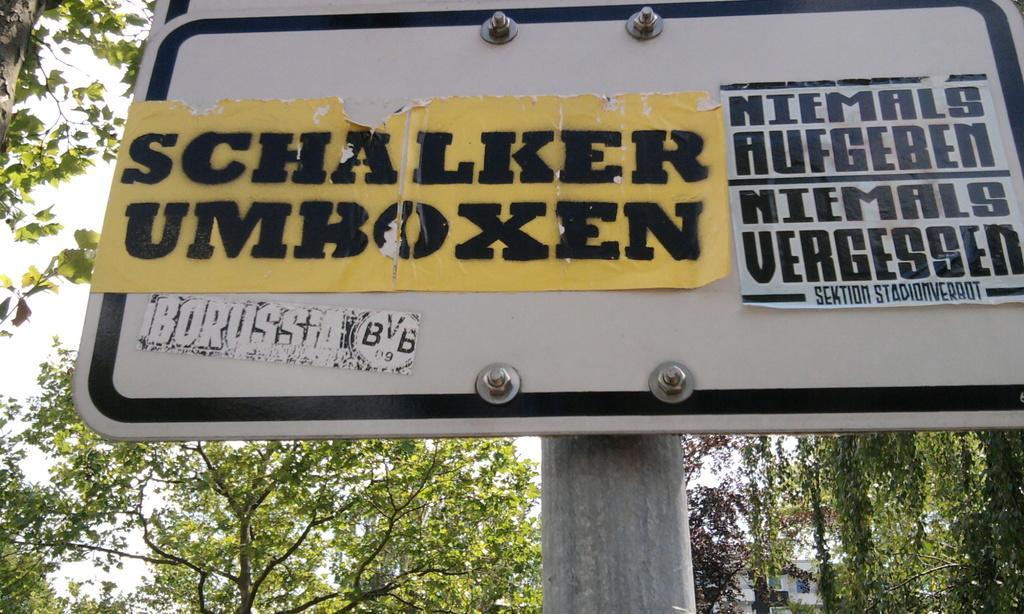How would you summarize this image in a sentence or two? Here in this picture we can see a board, which is present on a pole over there and we can see some posts stuck on it and behind it we can see trees present all over there. 